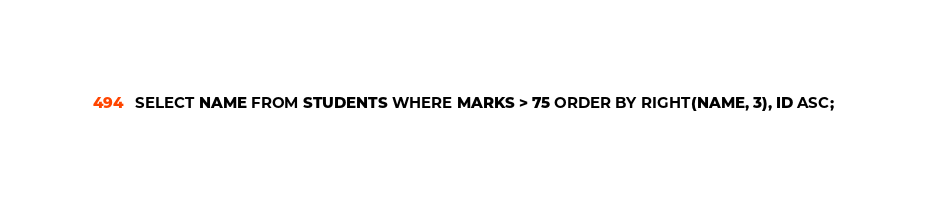Convert code to text. <code><loc_0><loc_0><loc_500><loc_500><_SQL_>SELECT NAME FROM STUDENTS WHERE MARKS > 75 ORDER BY RIGHT(NAME, 3), ID ASC; </code> 